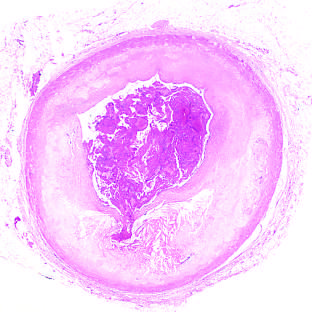what is acute coronary throm-bosis superimposed on?
Answer the question using a single word or phrase. An atherosclerotic plaque with focal disruption of the fibrous cap 